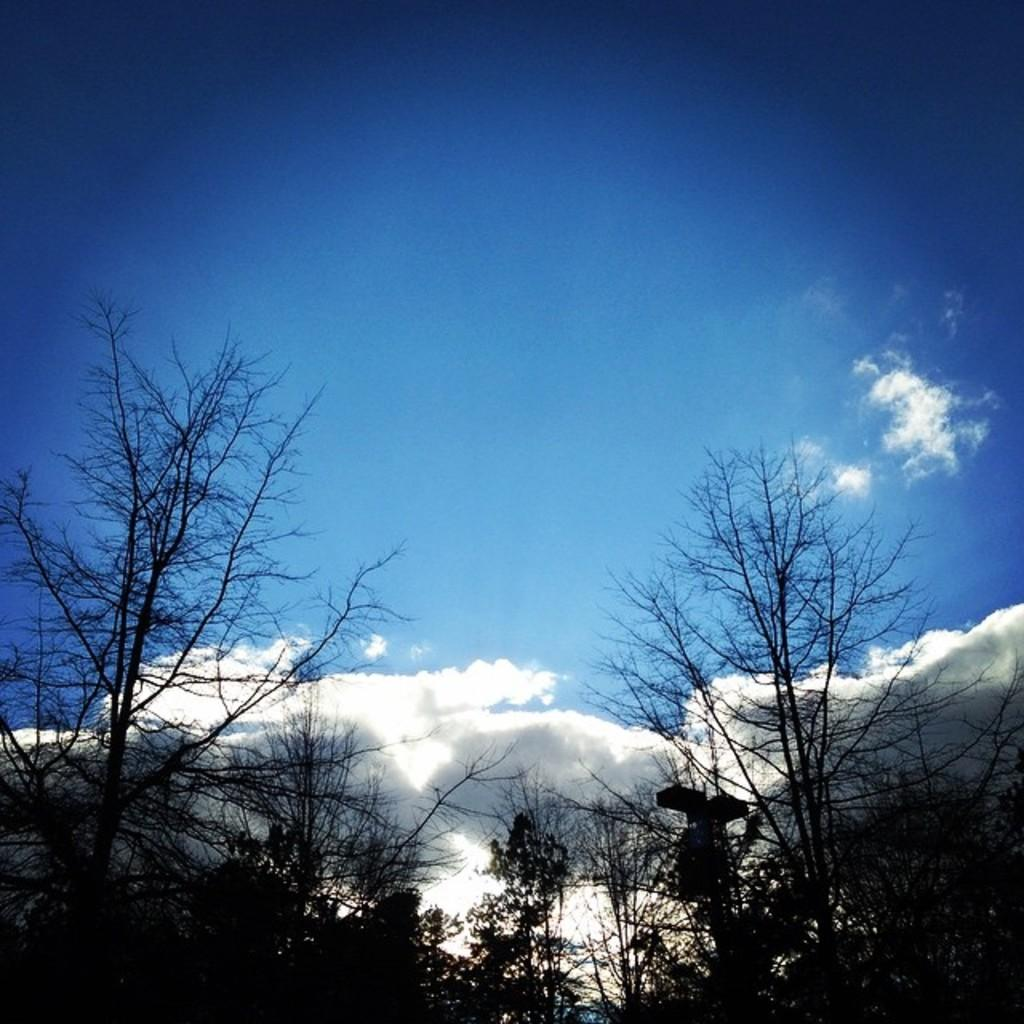What type of vegetation can be seen in the image? There are trees in the image. What part of the natural environment is visible in the image? The sky is visible in the image. What can be observed in the sky? Clouds are present in the sky. Can you see a yak grazing among the trees in the image? There is no yak present in the image; it only features trees and clouds in the sky. What type of record can be heard playing in the background of the image? There is no sound or record present in the image, as it is a still photograph. 